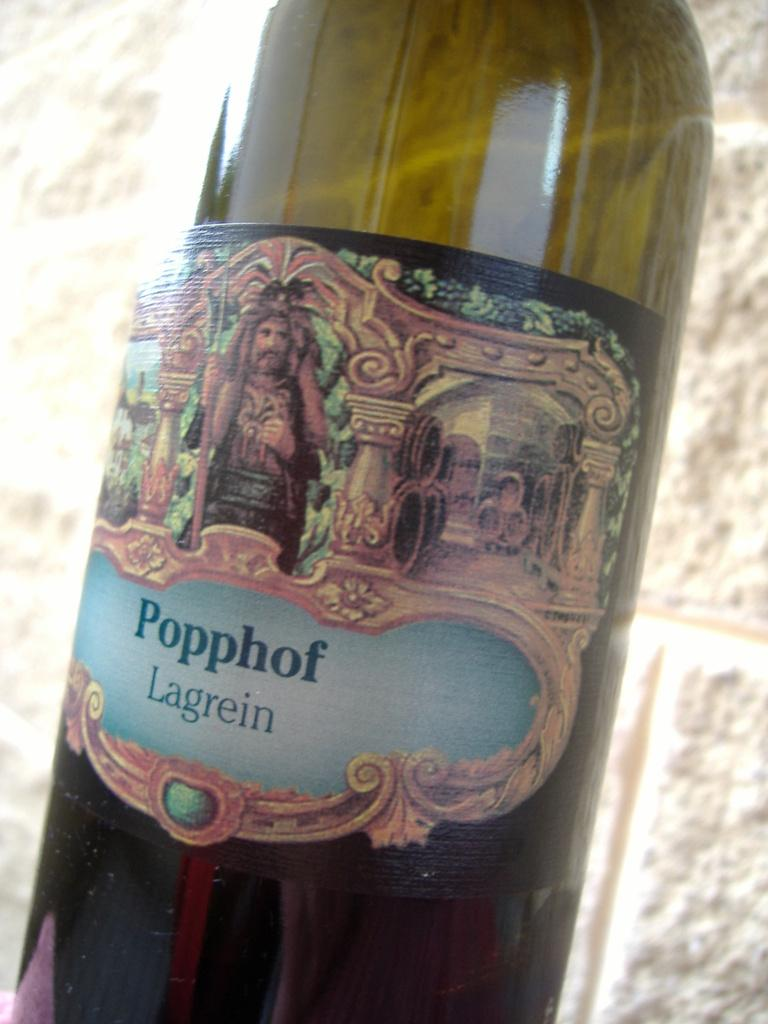<image>
Share a concise interpretation of the image provided. A bottle of Popphof Lagrein wine sits in the sunlight against a brick wall. 